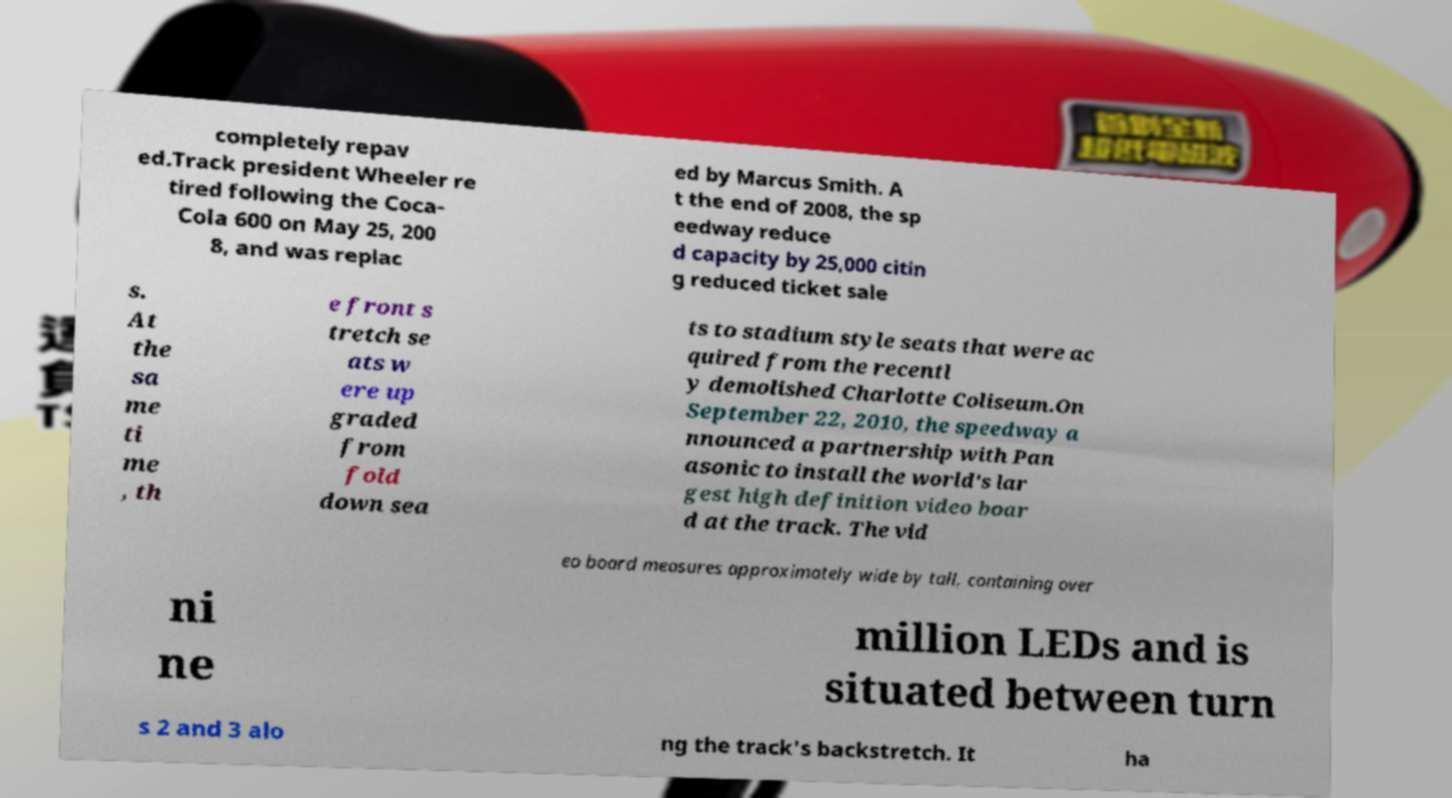Please read and relay the text visible in this image. What does it say? completely repav ed.Track president Wheeler re tired following the Coca- Cola 600 on May 25, 200 8, and was replac ed by Marcus Smith. A t the end of 2008, the sp eedway reduce d capacity by 25,000 citin g reduced ticket sale s. At the sa me ti me , th e front s tretch se ats w ere up graded from fold down sea ts to stadium style seats that were ac quired from the recentl y demolished Charlotte Coliseum.On September 22, 2010, the speedway a nnounced a partnership with Pan asonic to install the world's lar gest high definition video boar d at the track. The vid eo board measures approximately wide by tall, containing over ni ne million LEDs and is situated between turn s 2 and 3 alo ng the track's backstretch. It ha 